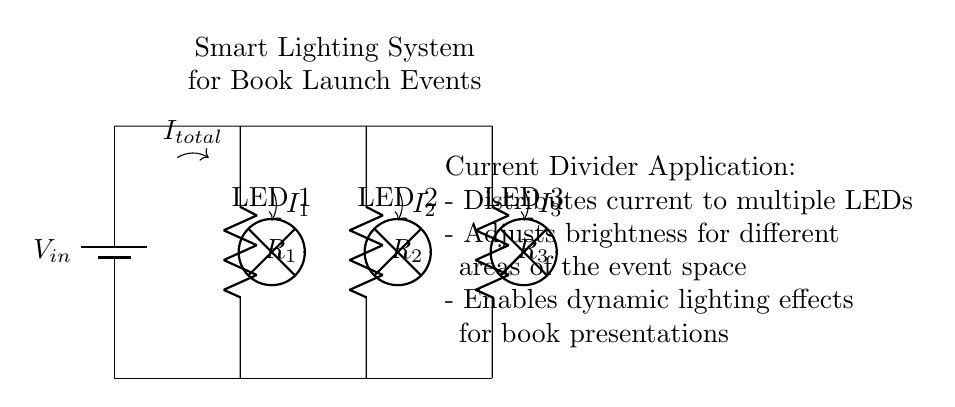what is the input voltage of this circuit? The input voltage, labeled as V_in, is the potential difference supplied to the circuit, but the specific value is not given in the diagram.
Answer: V_in how many resistors are in the circuit? The circuit diagram shows three resistors, labeled R_1, R_2, and R_3.
Answer: 3 which components are used for lighting in the circuit? The lighting components illustrated in the circuit diagram are three LEDs, labeled LED 1, LED 2, and LED 3.
Answer: LEDs how is the current distributed in the circuit? The circuit employs a current divider which allows the total current I_total to be split into smaller currents I_1, I_2, and I_3 through each of the resistors, connected in parallel to the LEDs.
Answer: Via a current divider what is the role of the current divider in a smart lighting system? The current divider distributes current to the three LEDs, enabling adjustable brightness and dynamic effects for different areas within the event space, enhancing the overall lighting quality during the book launch.
Answer: Distributes current for adjustable brightness what happens if one LED fails in the circuit? If one LED fails, the remaining LEDs will continue to receive their respective currents as they are in parallel, which helps maintain lighting functionality. The overall brightness may be affected depending on the resistor values.
Answer: Remaining LEDs stay lit how does this circuit allow for dynamic lighting effects? By adjusting the resistance values of the resistors R_1, R_2, and R_3 or using variable resistors, the brightness of each LED can be controlled independently, enabling the creation of various lighting scenarios for presentations.
Answer: Adjusting resistor values 